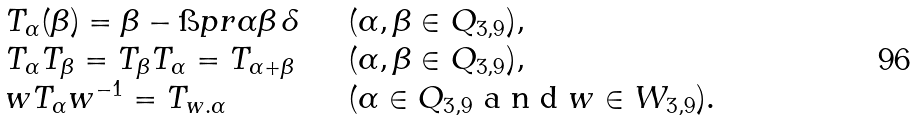<formula> <loc_0><loc_0><loc_500><loc_500>\begin{array} { l l } T _ { \alpha } ( \beta ) = \beta - \i p r { \alpha } { \beta } \, \delta \quad & ( \alpha , \beta \in Q _ { 3 , 9 } ) , \\ T _ { \alpha } T _ { \beta } = T _ { \beta } T _ { \alpha } = T _ { \alpha + \beta } \quad & ( \alpha , \beta \in Q _ { 3 , 9 } ) , \\ w T _ { \alpha } w ^ { - 1 } = T _ { w . \alpha } \quad & ( \alpha \in Q _ { 3 , 9 } $ a n d $ w \in W _ { 3 , 9 } ) . \end{array}</formula> 